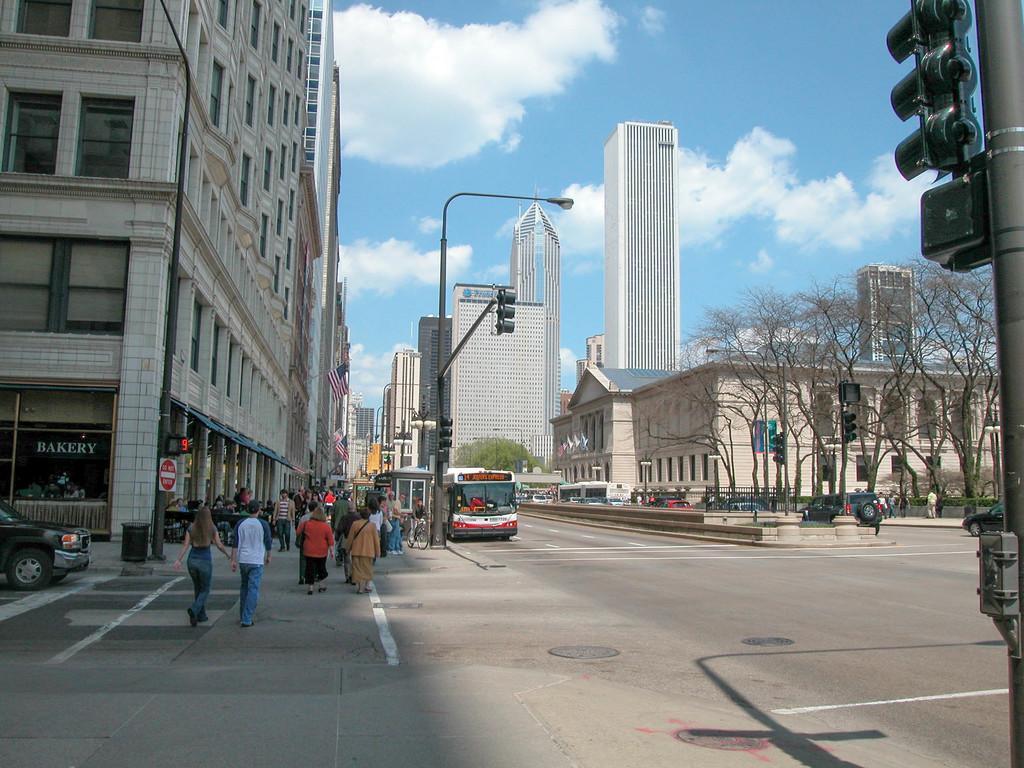In one or two sentences, can you explain what this image depicts? In this image many people are walking together ,In this image we can see a skyscrapers and a streetlights , A bus is standing and a group of trees beside a road. 